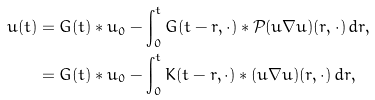Convert formula to latex. <formula><loc_0><loc_0><loc_500><loc_500>u ( t ) & = G ( t ) * u _ { 0 } - \int _ { 0 } ^ { t } G ( t - r , \cdot ) * { \mathcal { P } } ( u \nabla u ) ( r , \cdot ) \, d r , \\ & = G ( t ) * u _ { 0 } - \int _ { 0 } ^ { t } K ( t - r , \cdot ) * ( u \nabla u ) ( r , \cdot ) \, d r ,</formula> 